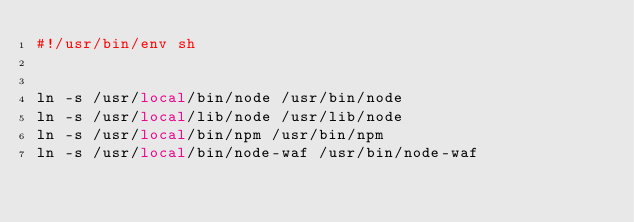Convert code to text. <code><loc_0><loc_0><loc_500><loc_500><_Bash_>#!/usr/bin/env sh


ln -s /usr/local/bin/node /usr/bin/node
ln -s /usr/local/lib/node /usr/lib/node
ln -s /usr/local/bin/npm /usr/bin/npm
ln -s /usr/local/bin/node-waf /usr/bin/node-waf

</code> 